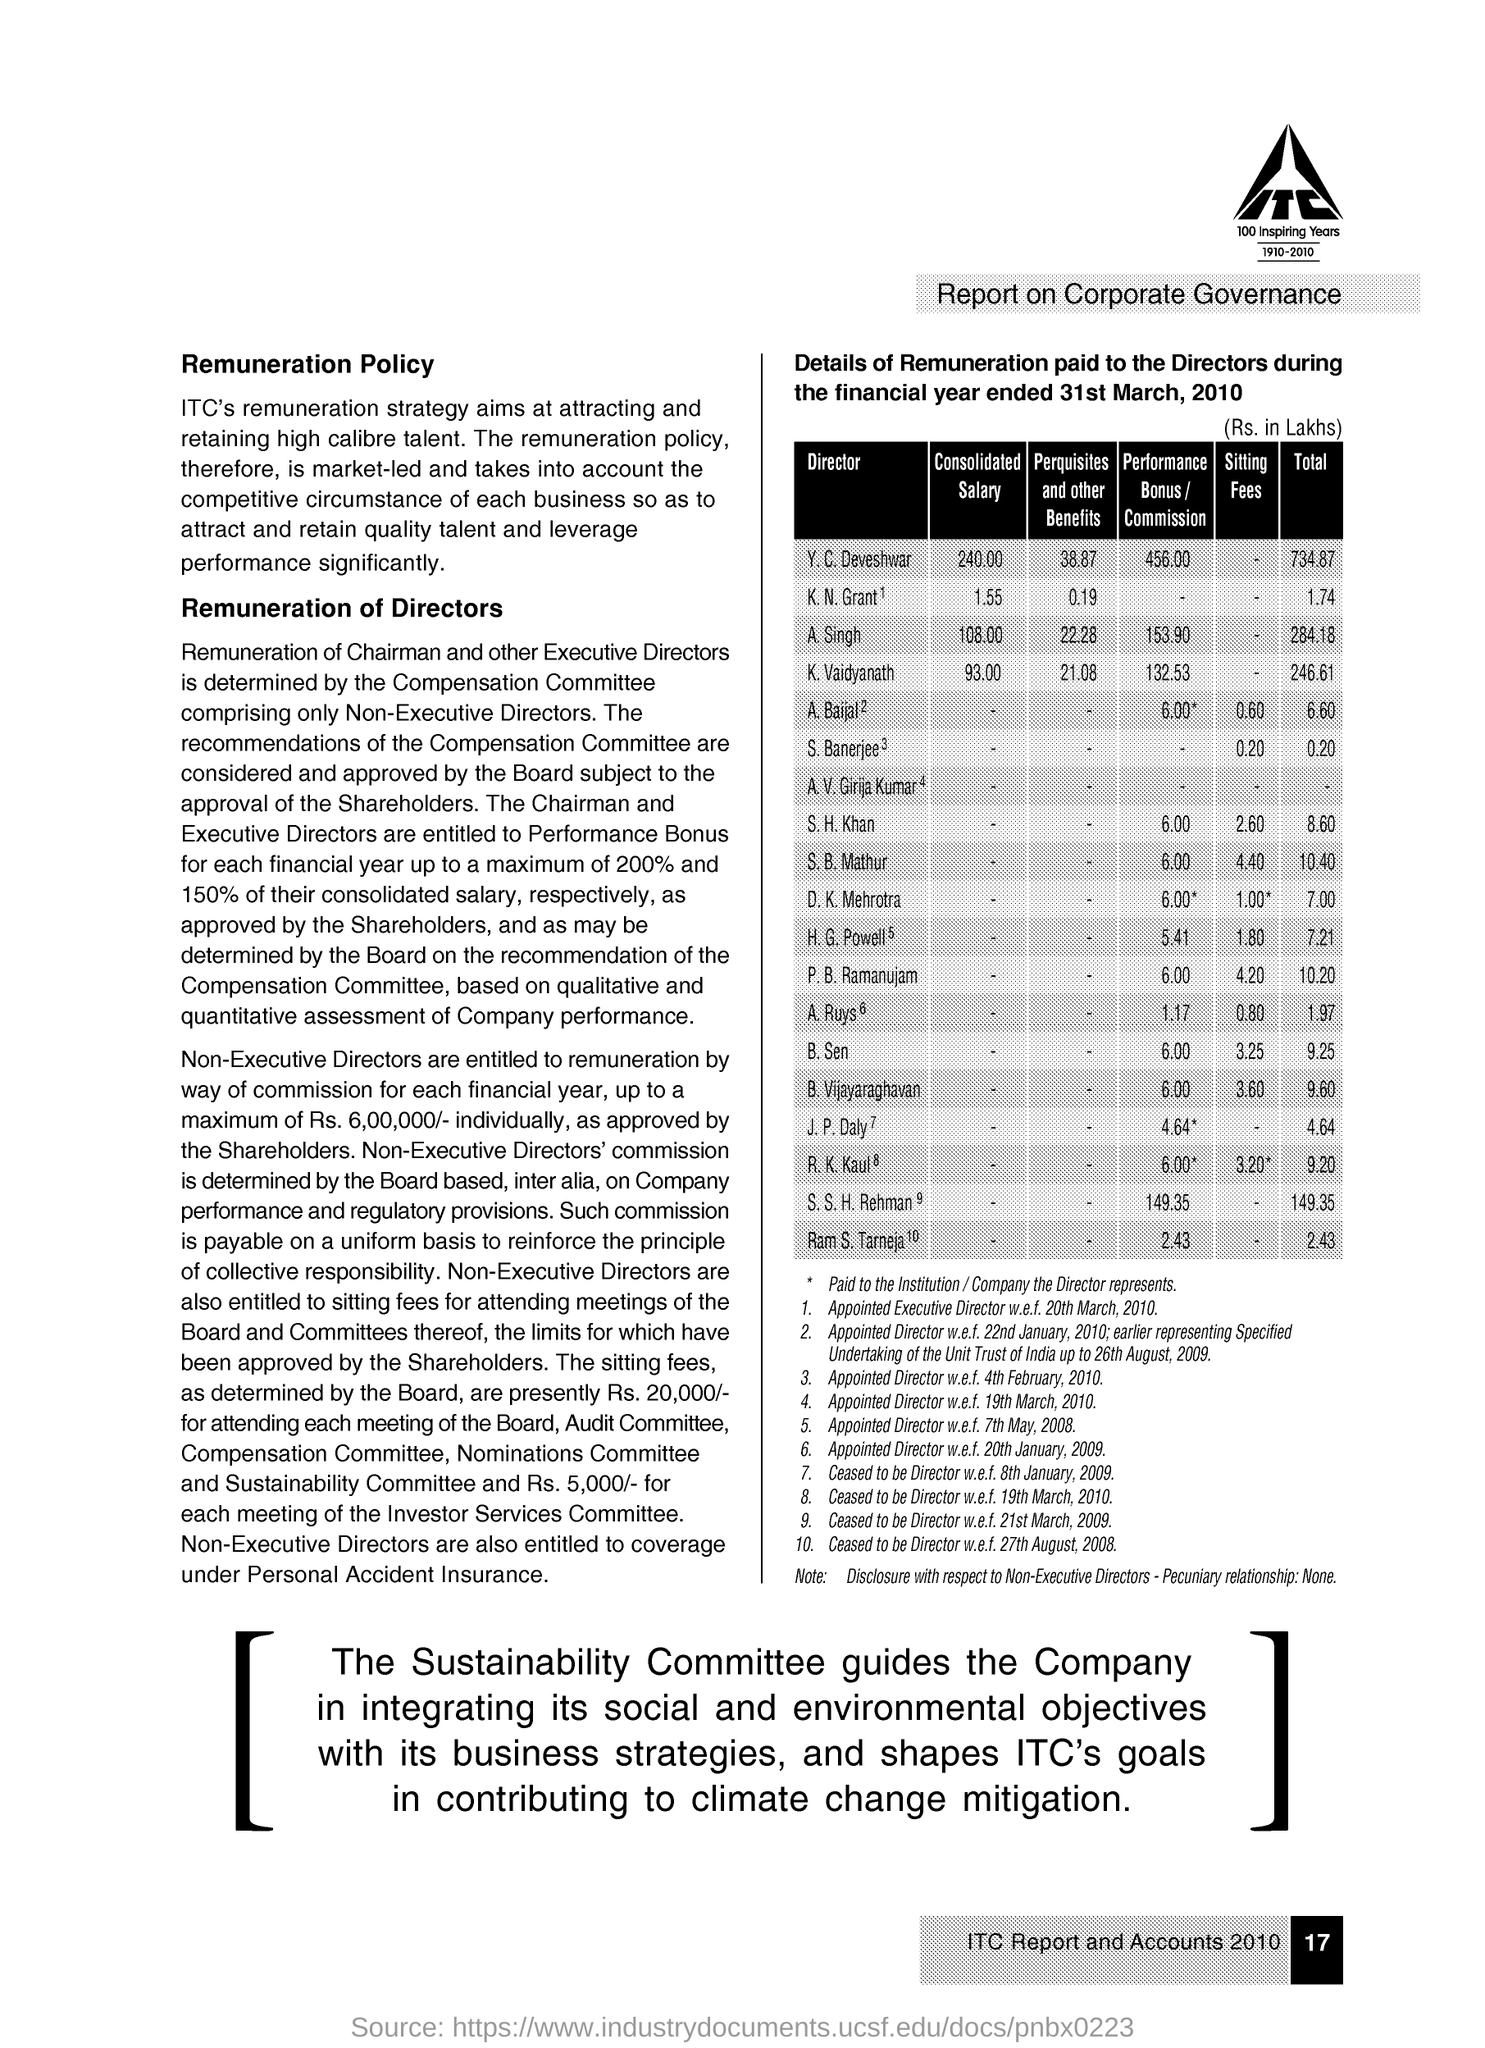Highlight a few significant elements in this photo. The salary of A Singh is consolidated and is equal to 108.00. The total amount of money received by K and N Grants was 1.74 crore. The performance bonus of S.H Khan is 6.00. The perquisites and other benefits of K.N Grant are 0.19. 